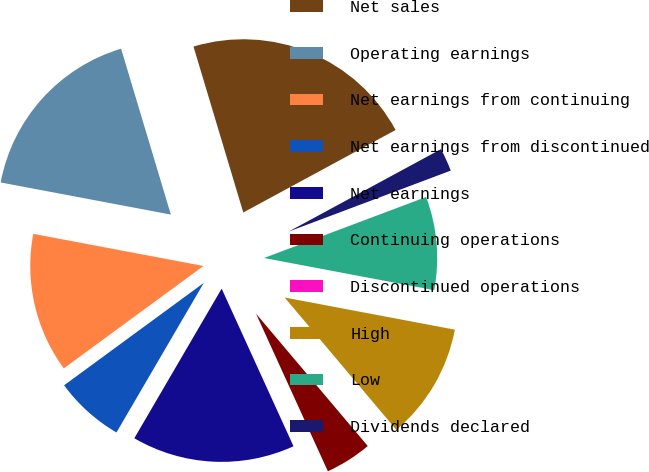Convert chart to OTSL. <chart><loc_0><loc_0><loc_500><loc_500><pie_chart><fcel>Net sales<fcel>Operating earnings<fcel>Net earnings from continuing<fcel>Net earnings from discontinued<fcel>Net earnings<fcel>Continuing operations<fcel>Discontinued operations<fcel>High<fcel>Low<fcel>Dividends declared<nl><fcel>21.74%<fcel>17.39%<fcel>13.04%<fcel>6.52%<fcel>15.22%<fcel>4.35%<fcel>0.0%<fcel>10.87%<fcel>8.7%<fcel>2.17%<nl></chart> 